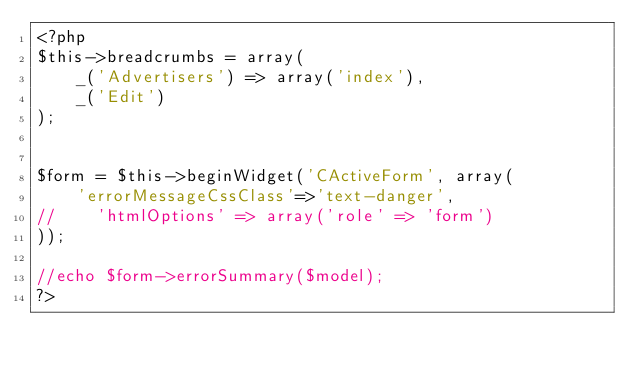Convert code to text. <code><loc_0><loc_0><loc_500><loc_500><_PHP_><?php
$this->breadcrumbs = array(
    _('Advertisers') => array('index'),
    _('Edit')
);


$form = $this->beginWidget('CActiveForm', array(
    'errorMessageCssClass'=>'text-danger',
//    'htmlOptions' => array('role' => 'form')
));

//echo $form->errorSummary($model);
?>
</code> 